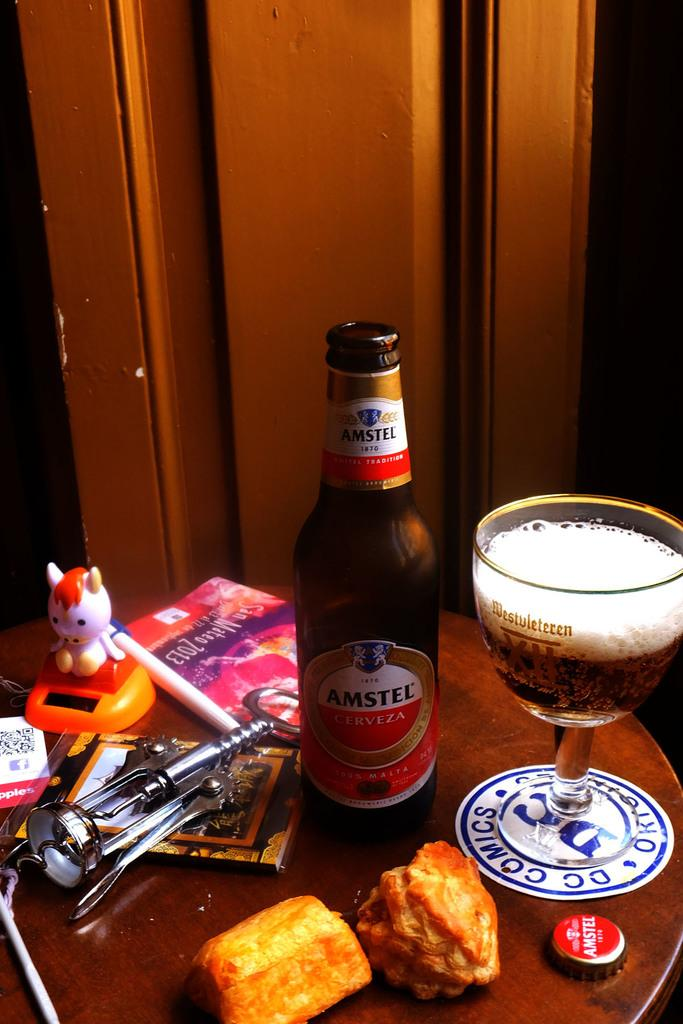Provide a one-sentence caption for the provided image. A beer called Amestel Cerveza sits on a table. 